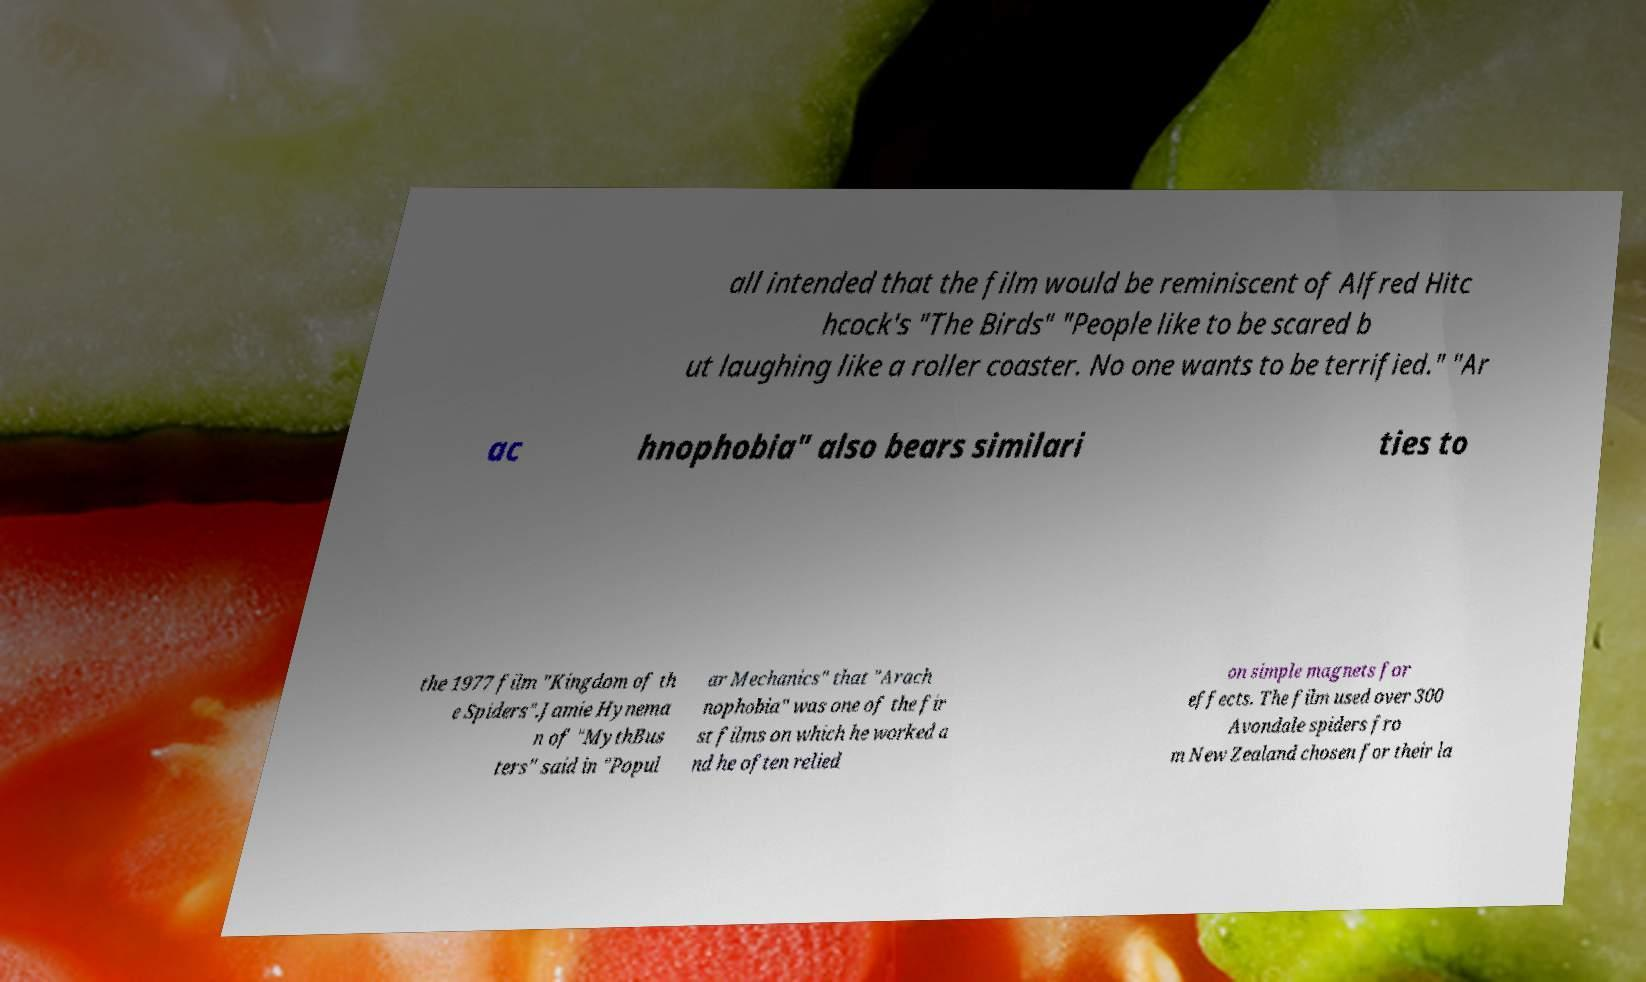What messages or text are displayed in this image? I need them in a readable, typed format. all intended that the film would be reminiscent of Alfred Hitc hcock's "The Birds" "People like to be scared b ut laughing like a roller coaster. No one wants to be terrified." "Ar ac hnophobia" also bears similari ties to the 1977 film "Kingdom of th e Spiders".Jamie Hynema n of "MythBus ters" said in "Popul ar Mechanics" that "Arach nophobia" was one of the fir st films on which he worked a nd he often relied on simple magnets for effects. The film used over 300 Avondale spiders fro m New Zealand chosen for their la 